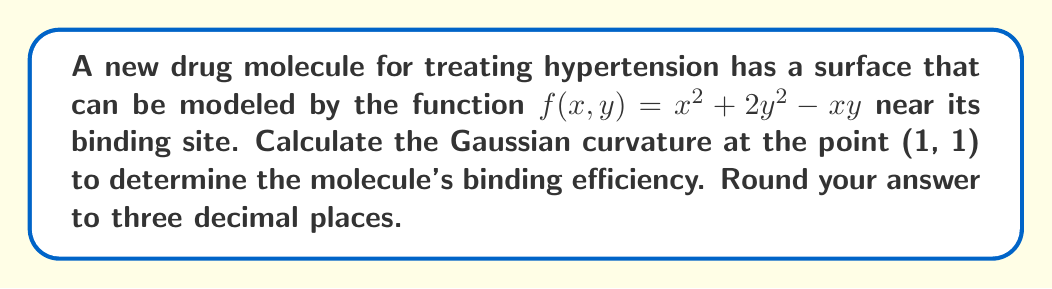Help me with this question. To calculate the Gaussian curvature, we need to follow these steps:

1) The Gaussian curvature K is given by:

   $$K = \frac{f_{xx}f_{yy} - f_{xy}^2}{(1 + f_x^2 + f_y^2)^2}$$

   where subscripts denote partial derivatives.

2) Calculate the partial derivatives:
   
   $f_x = 2x - y$
   $f_y = 4y - x$
   $f_{xx} = 2$
   $f_{yy} = 4$
   $f_{xy} = -1$

3) Evaluate these at the point (1, 1):
   
   $f_x(1,1) = 2(1) - 1 = 1$
   $f_y(1,1) = 4(1) - 1 = 3$
   $f_{xx}(1,1) = 2$
   $f_{yy}(1,1) = 4$
   $f_{xy}(1,1) = -1$

4) Substitute into the Gaussian curvature formula:

   $$K = \frac{(2)(4) - (-1)^2}{(1 + 1^2 + 3^2)^2}$$

5) Simplify:
   
   $$K = \frac{8 - 1}{(1 + 1 + 9)^2} = \frac{7}{11^2} = \frac{7}{121} \approx 0.058$$

6) Round to three decimal places: 0.058
Answer: 0.058 